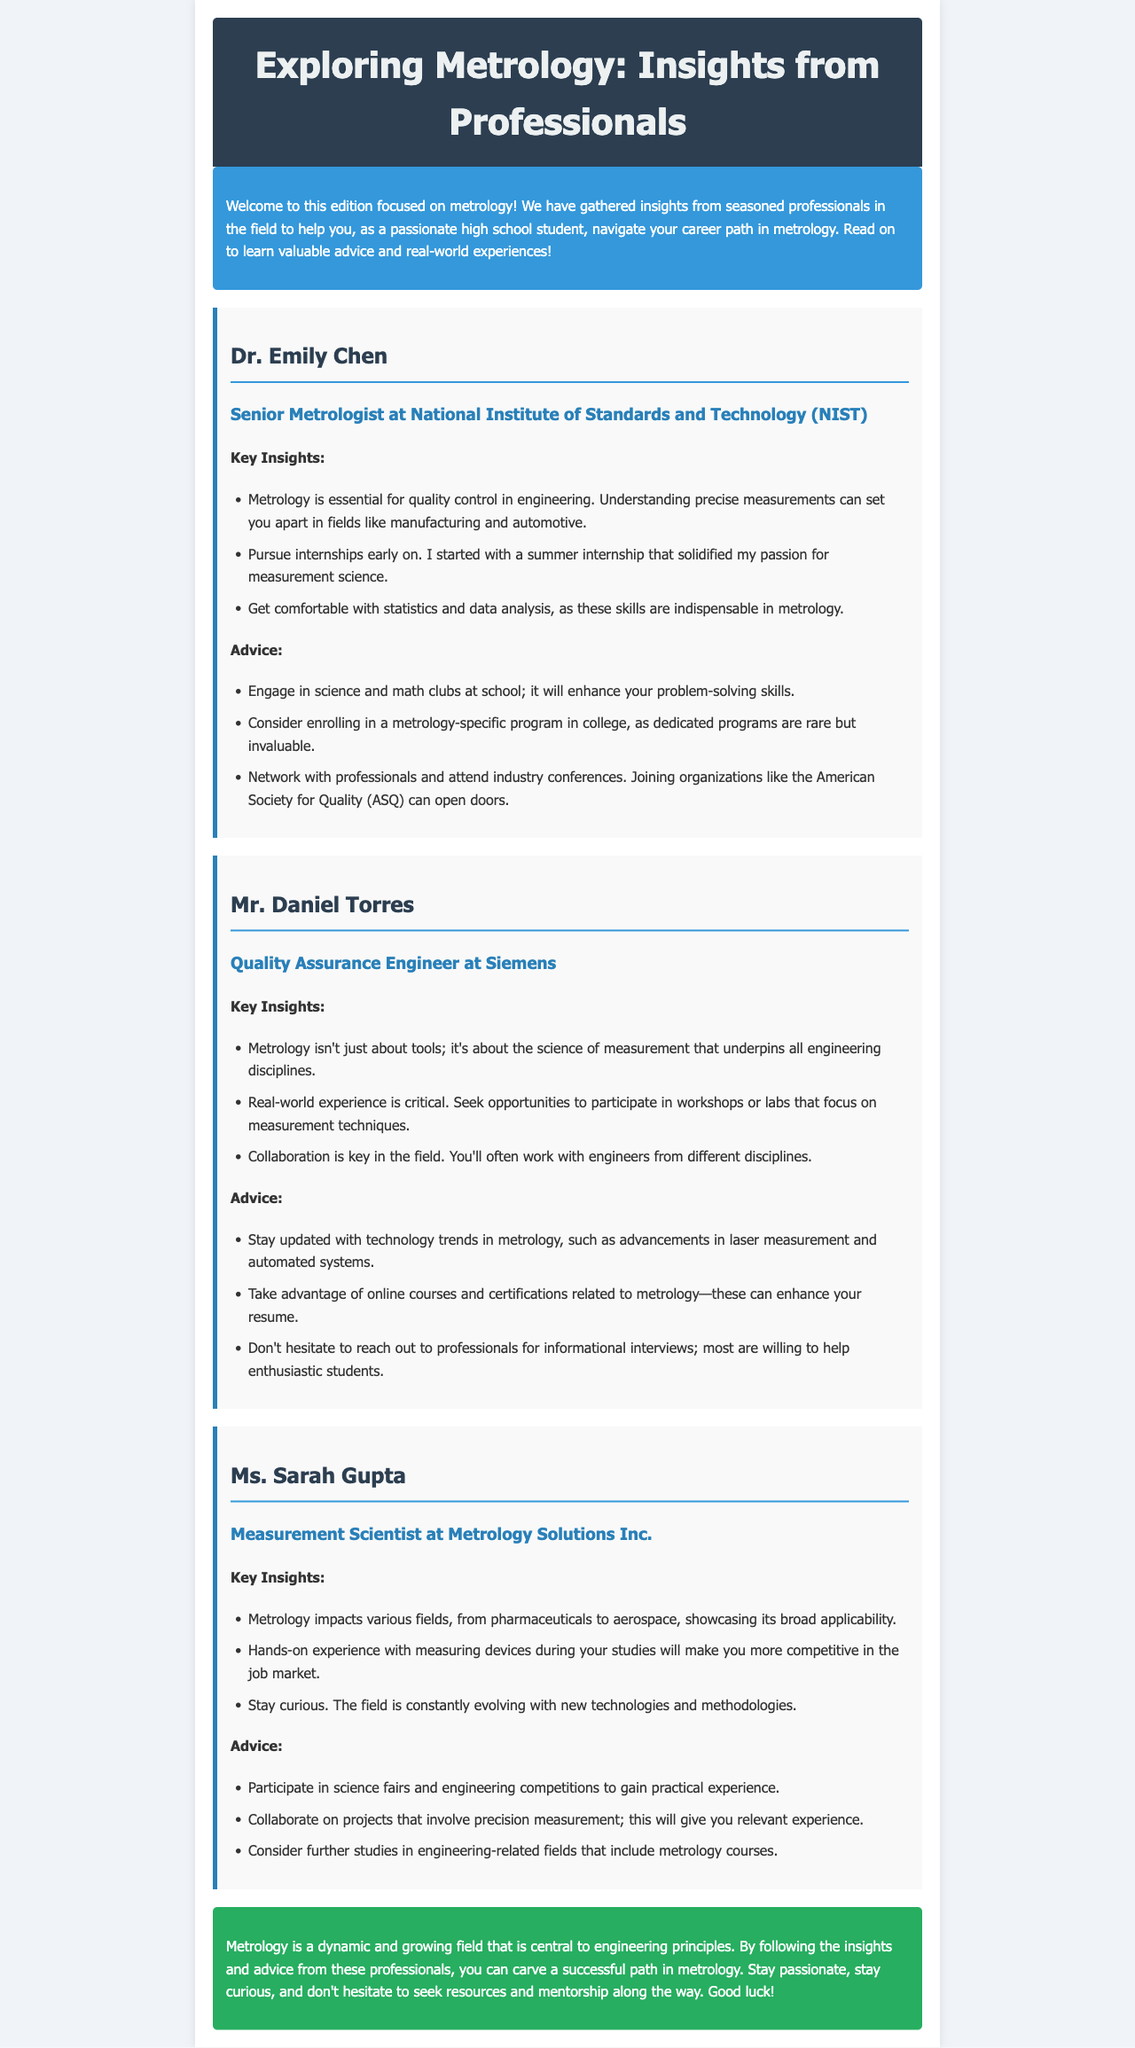What is metrology? Metrology is mentioned as essential for quality control in engineering and involves precise measurements.
Answer: Essential for quality control in engineering Who is the Senior Metrologist at NIST? The document introduces Dr. Emily Chen as the Senior Metrologist at the National Institute of Standards and Technology.
Answer: Dr. Emily Chen Which organization is mentioned for networking opportunities? The advice section suggests joining the American Society for Quality for networking opportunities.
Answer: American Society for Quality (ASQ) What is a key skill emphasized by Dr. Emily Chen? Dr. Emily Chen emphasizes getting comfortable with statistics and data analysis as indispensable skills in metrology.
Answer: Statistics and data analysis What advice does Mr. Daniel Torres give about technology trends? Mr. Daniel Torres advises staying updated with technology trends in metrology, specifically mentioning advancements in laser measurement and automated systems.
Answer: Advancements in laser measurement and automated systems How can students gain practical experience according to Ms. Sarah Gupta? Ms. Sarah Gupta suggests participating in science fairs and engineering competitions to gain practical experience.
Answer: Science fairs and engineering competitions What is a common theme among the advice given by professionals in the document? A common theme is engaging in hands-on experiences and networking to enhance career opportunities in metrology.
Answer: Engaging in hands-on experiences and networking How many professionals are interviewed in the document? The document features interviews with three professionals in the field of metrology.
Answer: Three professionals What is the background color of the intro section? The background color of the intro section is blue.
Answer: Blue 